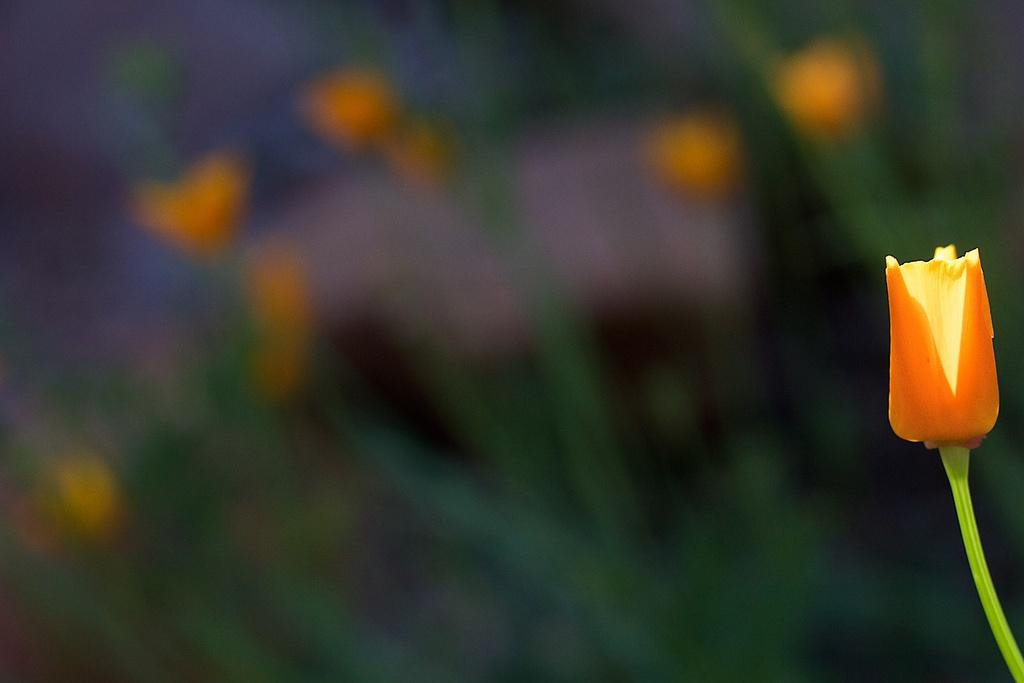What type of flower can be seen in the image? There is an orange color flower in the image. What type of frame is around the bear in the image? There is no bear or frame present in the image; it only features an orange color flower. 